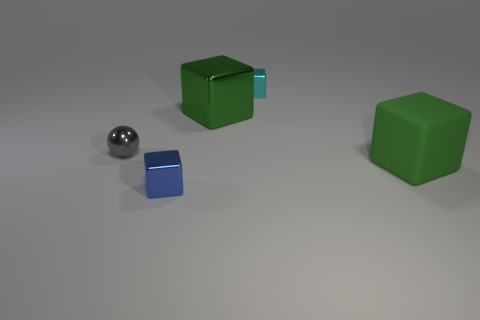Are there any red cylinders that have the same size as the gray object?
Ensure brevity in your answer.  No. There is a green thing that is the same size as the matte cube; what is its shape?
Make the answer very short. Cube. How many other things are the same color as the small metal ball?
Your answer should be compact. 0. What shape is the object that is both to the right of the green metallic cube and in front of the tiny cyan cube?
Your answer should be very brief. Cube. Are there any tiny gray things on the right side of the small cube that is behind the tiny thing in front of the big matte object?
Keep it short and to the point. No. How many other objects are the same material as the blue cube?
Give a very brief answer. 3. How many shiny balls are there?
Your answer should be very brief. 1. How many things are rubber blocks or green objects in front of the gray ball?
Your response must be concise. 1. Is there anything else that is the same shape as the blue object?
Provide a short and direct response. Yes. Do the cyan block that is behind the blue shiny cube and the green metal thing have the same size?
Ensure brevity in your answer.  No. 